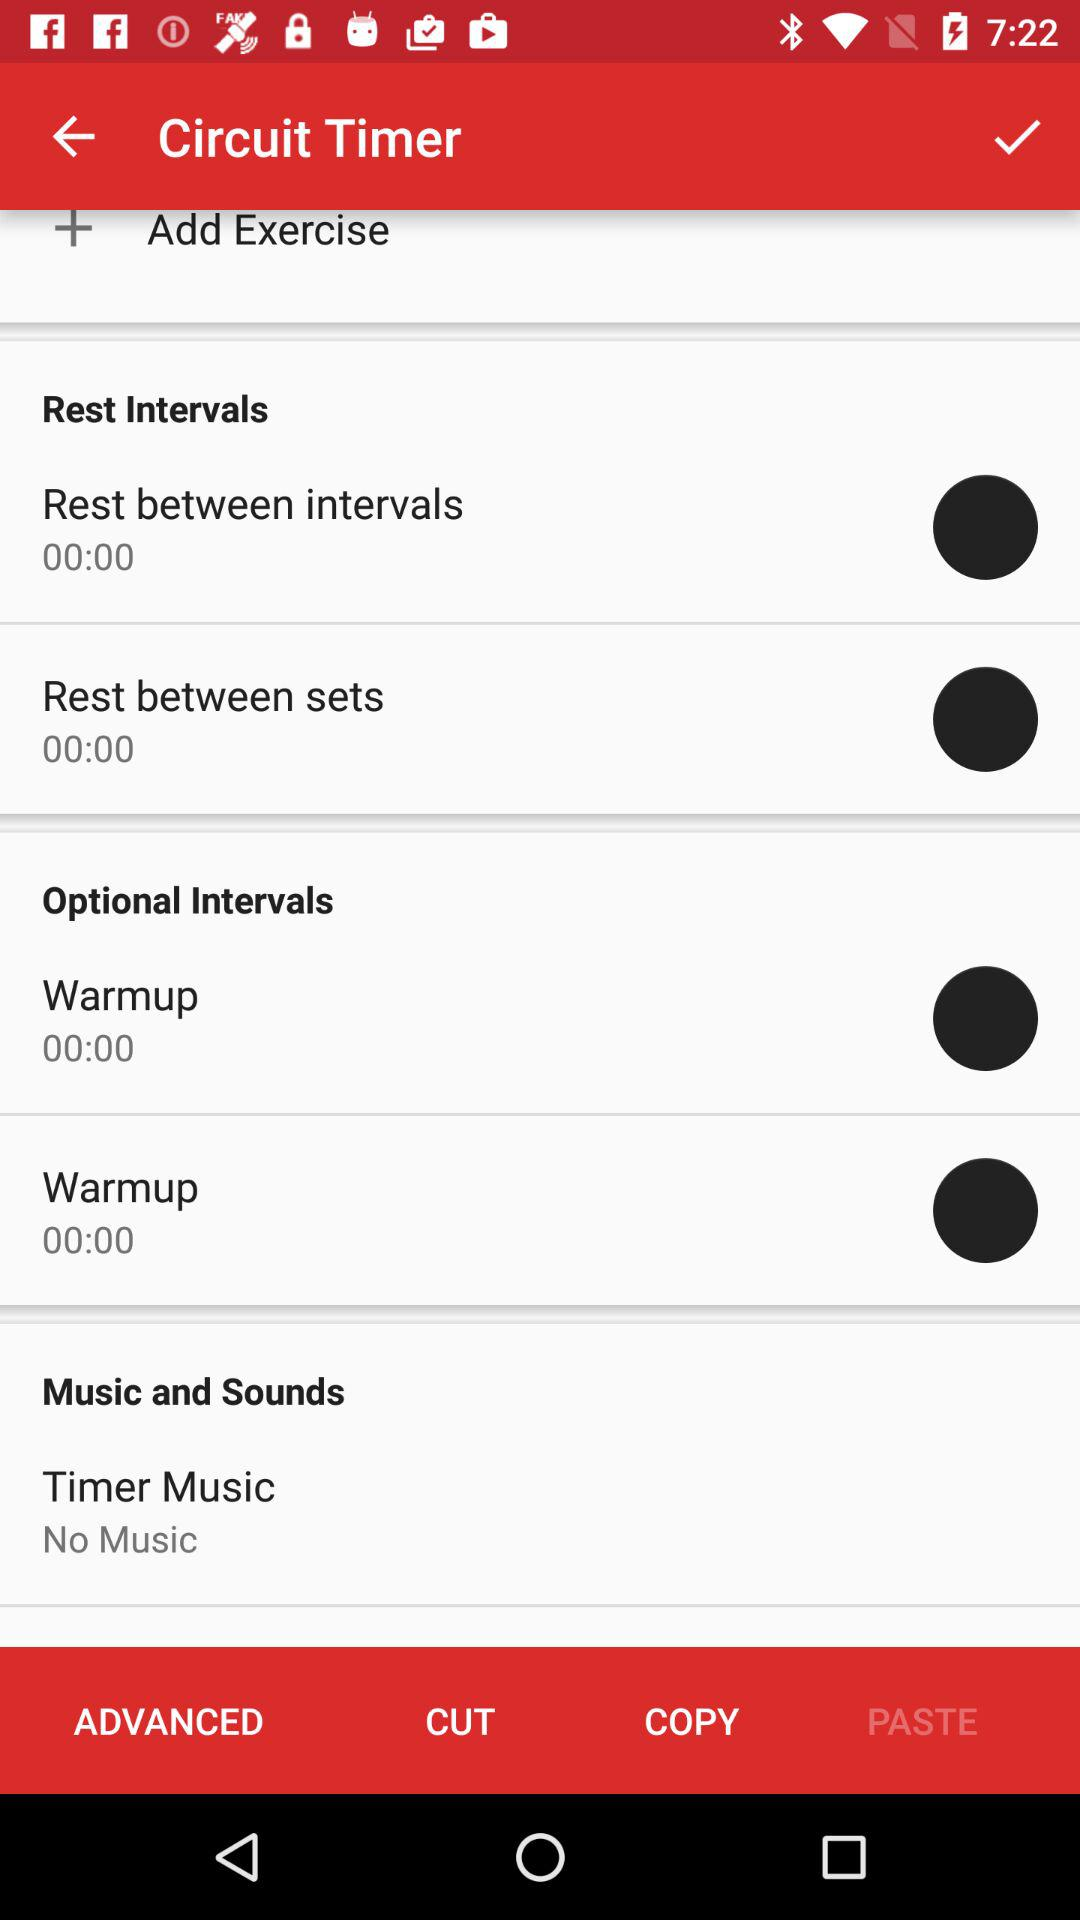What is the status of Rest between sets?
When the provided information is insufficient, respond with <no answer>. <no answer> 